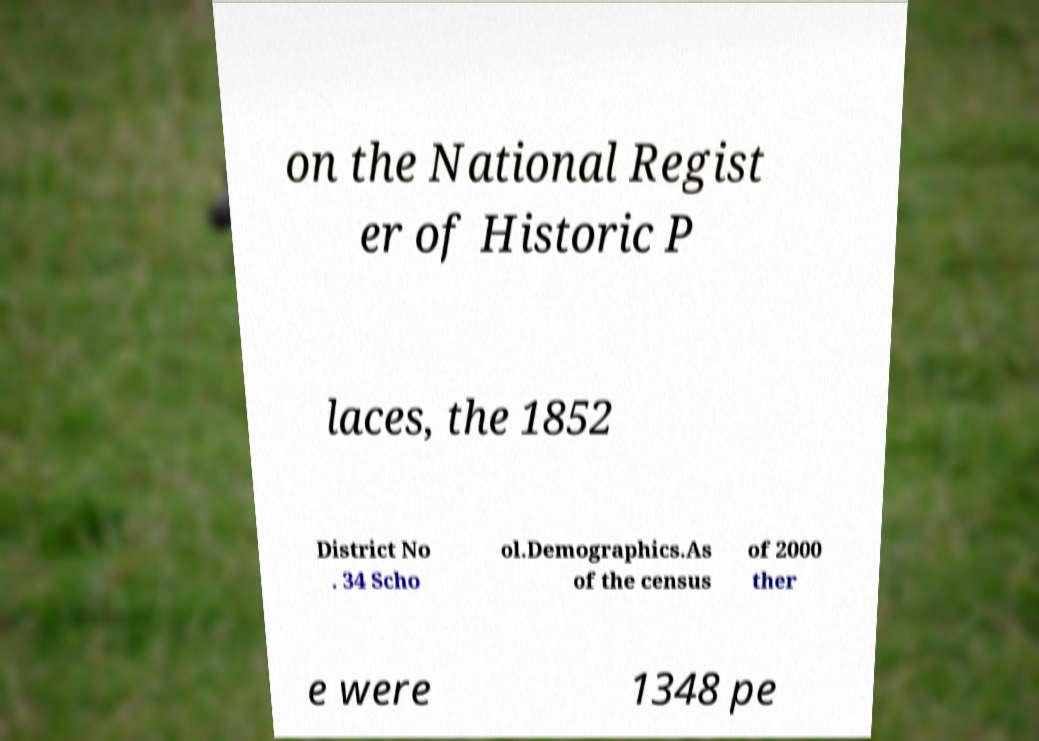Please read and relay the text visible in this image. What does it say? on the National Regist er of Historic P laces, the 1852 District No . 34 Scho ol.Demographics.As of the census of 2000 ther e were 1348 pe 